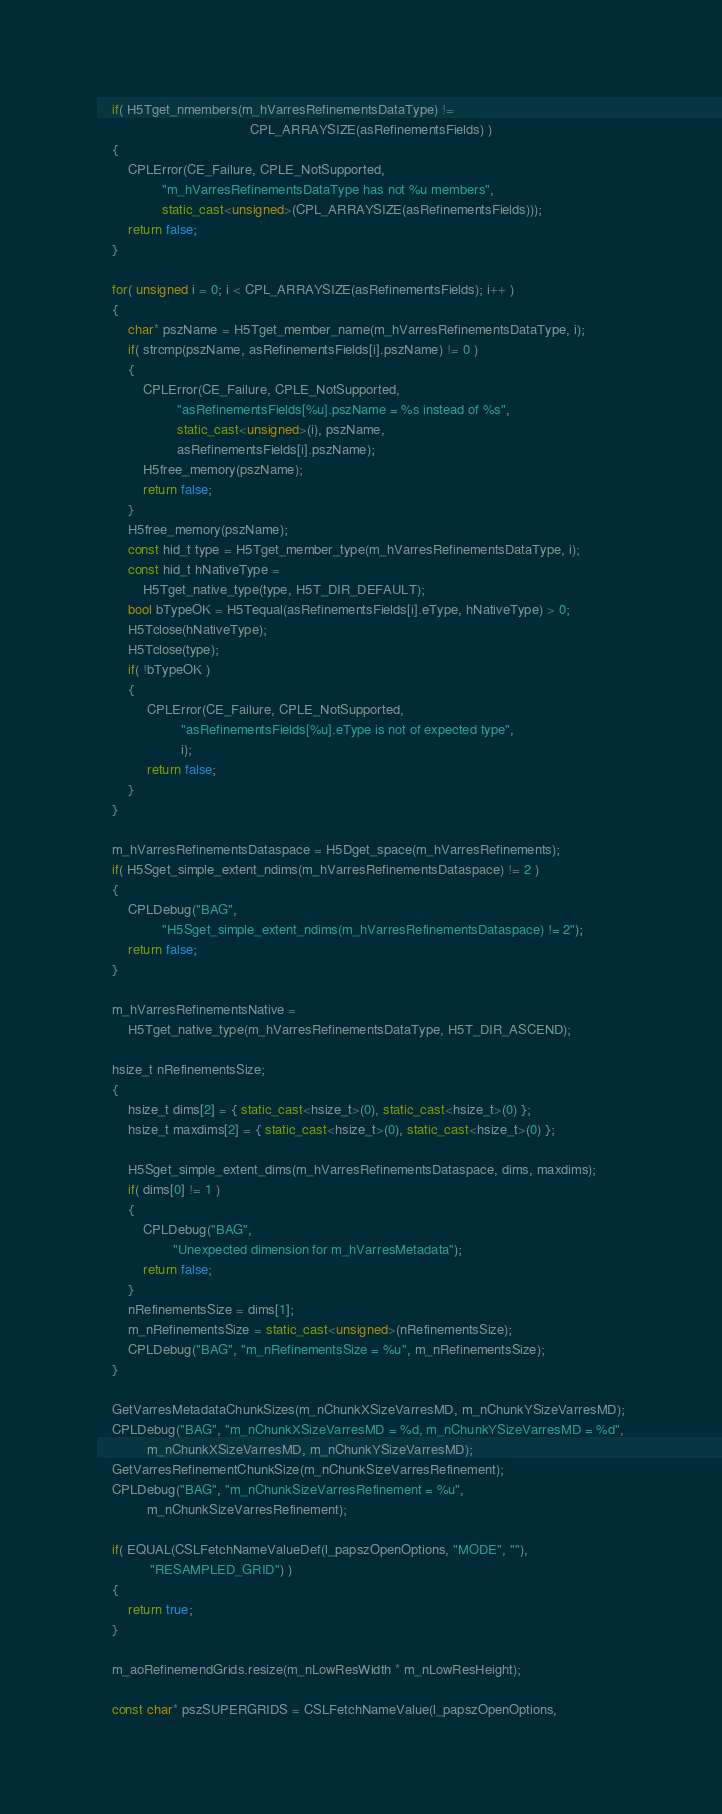<code> <loc_0><loc_0><loc_500><loc_500><_C++_>    if( H5Tget_nmembers(m_hVarresRefinementsDataType) !=
                                        CPL_ARRAYSIZE(asRefinementsFields) )
    {
        CPLError(CE_Failure, CPLE_NotSupported,
                 "m_hVarresRefinementsDataType has not %u members",
                 static_cast<unsigned>(CPL_ARRAYSIZE(asRefinementsFields)));
        return false;
    }

    for( unsigned i = 0; i < CPL_ARRAYSIZE(asRefinementsFields); i++ )
    {
        char* pszName = H5Tget_member_name(m_hVarresRefinementsDataType, i);
        if( strcmp(pszName, asRefinementsFields[i].pszName) != 0 )
        {
            CPLError(CE_Failure, CPLE_NotSupported,
                     "asRefinementsFields[%u].pszName = %s instead of %s",
                     static_cast<unsigned>(i), pszName,
                     asRefinementsFields[i].pszName);
            H5free_memory(pszName);
            return false;
        }
        H5free_memory(pszName);
        const hid_t type = H5Tget_member_type(m_hVarresRefinementsDataType, i);
        const hid_t hNativeType =
            H5Tget_native_type(type, H5T_DIR_DEFAULT);
        bool bTypeOK = H5Tequal(asRefinementsFields[i].eType, hNativeType) > 0;
        H5Tclose(hNativeType);
        H5Tclose(type);
        if( !bTypeOK )
        {
             CPLError(CE_Failure, CPLE_NotSupported,
                      "asRefinementsFields[%u].eType is not of expected type",
                      i);
             return false;
        }
    }

    m_hVarresRefinementsDataspace = H5Dget_space(m_hVarresRefinements);
    if( H5Sget_simple_extent_ndims(m_hVarresRefinementsDataspace) != 2 )
    {
        CPLDebug("BAG",
                 "H5Sget_simple_extent_ndims(m_hVarresRefinementsDataspace) != 2");
        return false;
    }

    m_hVarresRefinementsNative =
        H5Tget_native_type(m_hVarresRefinementsDataType, H5T_DIR_ASCEND);

    hsize_t nRefinementsSize;
    {
        hsize_t dims[2] = { static_cast<hsize_t>(0), static_cast<hsize_t>(0) };
        hsize_t maxdims[2] = { static_cast<hsize_t>(0), static_cast<hsize_t>(0) };

        H5Sget_simple_extent_dims(m_hVarresRefinementsDataspace, dims, maxdims);
        if( dims[0] != 1 )
        {
            CPLDebug("BAG",
                    "Unexpected dimension for m_hVarresMetadata");
            return false;
        }
        nRefinementsSize = dims[1];
        m_nRefinementsSize = static_cast<unsigned>(nRefinementsSize);
        CPLDebug("BAG", "m_nRefinementsSize = %u", m_nRefinementsSize);
    }

    GetVarresMetadataChunkSizes(m_nChunkXSizeVarresMD, m_nChunkYSizeVarresMD);
    CPLDebug("BAG", "m_nChunkXSizeVarresMD = %d, m_nChunkYSizeVarresMD = %d",
             m_nChunkXSizeVarresMD, m_nChunkYSizeVarresMD);
    GetVarresRefinementChunkSize(m_nChunkSizeVarresRefinement);
    CPLDebug("BAG", "m_nChunkSizeVarresRefinement = %u",
             m_nChunkSizeVarresRefinement);

    if( EQUAL(CSLFetchNameValueDef(l_papszOpenOptions, "MODE", ""),
              "RESAMPLED_GRID") )
    {
        return true;
    }

    m_aoRefinemendGrids.resize(m_nLowResWidth * m_nLowResHeight);

    const char* pszSUPERGRIDS = CSLFetchNameValue(l_papszOpenOptions,</code> 